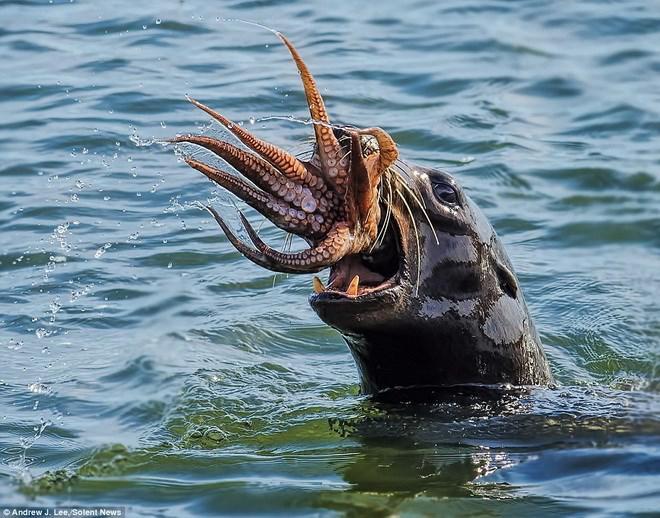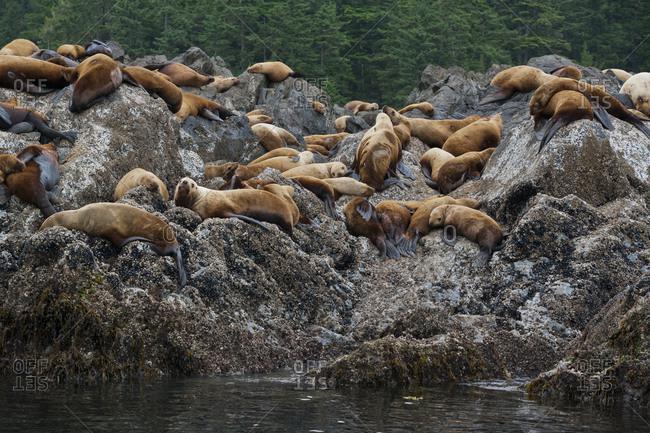The first image is the image on the left, the second image is the image on the right. Analyze the images presented: Is the assertion "All seals in the right image are out of the water." valid? Answer yes or no. Yes. The first image is the image on the left, the second image is the image on the right. Examine the images to the left and right. Is the description "Both images show masses of seals on natural rock formations above the water." accurate? Answer yes or no. No. 